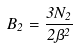Convert formula to latex. <formula><loc_0><loc_0><loc_500><loc_500>B _ { 2 } = \frac { 3 N _ { 2 } } { 2 \beta ^ { 2 } }</formula> 